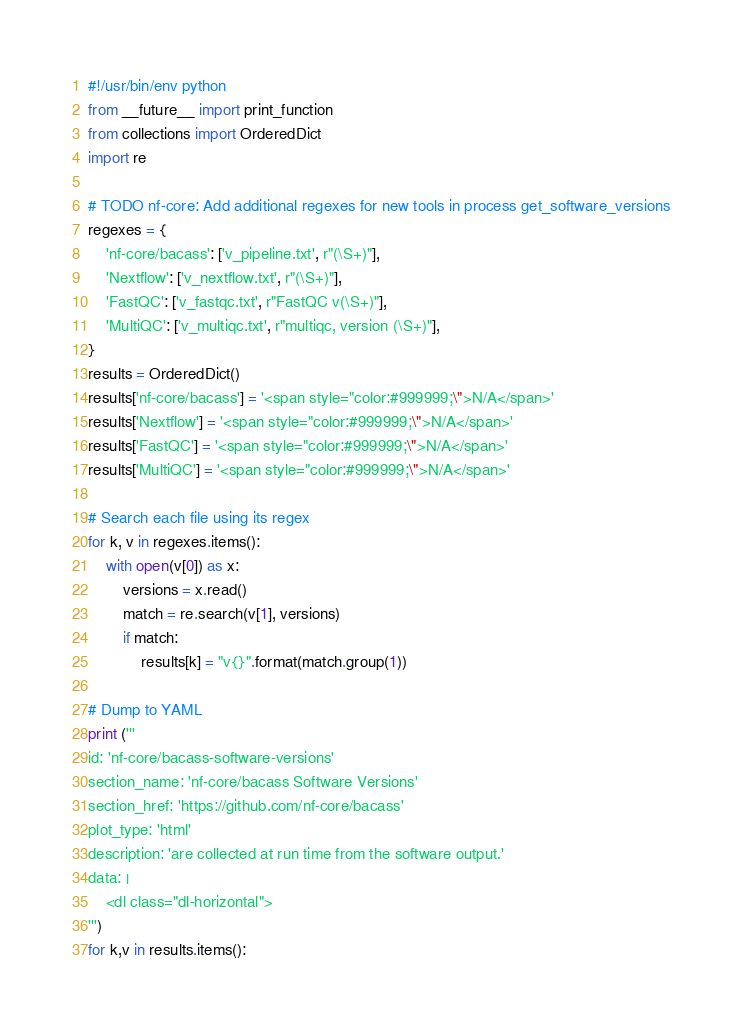<code> <loc_0><loc_0><loc_500><loc_500><_Python_>#!/usr/bin/env python
from __future__ import print_function
from collections import OrderedDict
import re

# TODO nf-core: Add additional regexes for new tools in process get_software_versions
regexes = {
    'nf-core/bacass': ['v_pipeline.txt', r"(\S+)"],
    'Nextflow': ['v_nextflow.txt', r"(\S+)"],
    'FastQC': ['v_fastqc.txt', r"FastQC v(\S+)"],
    'MultiQC': ['v_multiqc.txt', r"multiqc, version (\S+)"],
}
results = OrderedDict()
results['nf-core/bacass'] = '<span style="color:#999999;\">N/A</span>'
results['Nextflow'] = '<span style="color:#999999;\">N/A</span>'
results['FastQC'] = '<span style="color:#999999;\">N/A</span>'
results['MultiQC'] = '<span style="color:#999999;\">N/A</span>'

# Search each file using its regex
for k, v in regexes.items():
    with open(v[0]) as x:
        versions = x.read()
        match = re.search(v[1], versions)
        if match:
            results[k] = "v{}".format(match.group(1))

# Dump to YAML
print ('''
id: 'nf-core/bacass-software-versions'
section_name: 'nf-core/bacass Software Versions'
section_href: 'https://github.com/nf-core/bacass'
plot_type: 'html'
description: 'are collected at run time from the software output.'
data: |
    <dl class="dl-horizontal">
''')
for k,v in results.items():</code> 